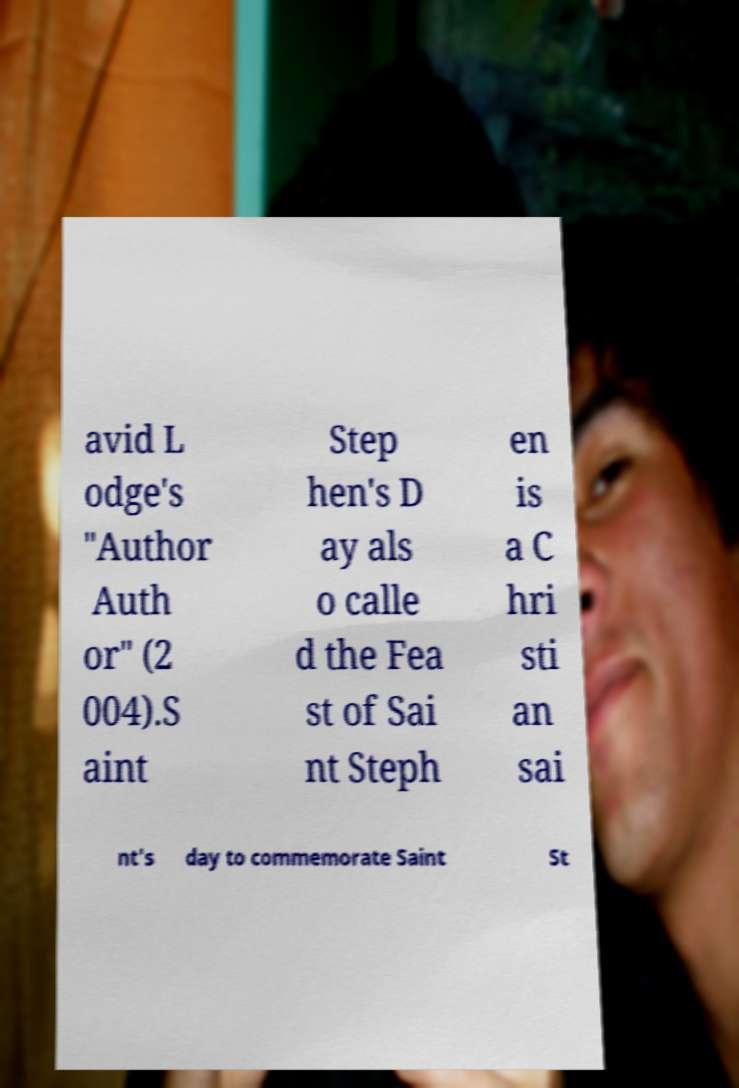I need the written content from this picture converted into text. Can you do that? avid L odge's "Author Auth or" (2 004).S aint Step hen's D ay als o calle d the Fea st of Sai nt Steph en is a C hri sti an sai nt's day to commemorate Saint St 